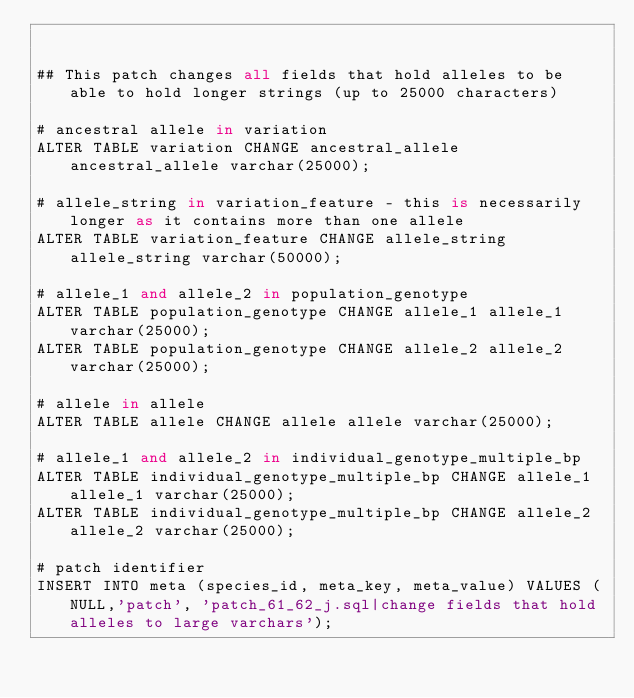<code> <loc_0><loc_0><loc_500><loc_500><_SQL_>

## This patch changes all fields that hold alleles to be able to hold longer strings (up to 25000 characters)

# ancestral allele in variation
ALTER TABLE variation CHANGE ancestral_allele ancestral_allele varchar(25000);

# allele_string in variation_feature - this is necessarily longer as it contains more than one allele
ALTER TABLE variation_feature CHANGE allele_string allele_string varchar(50000);

# allele_1 and allele_2 in population_genotype
ALTER TABLE population_genotype CHANGE allele_1 allele_1 varchar(25000);
ALTER TABLE population_genotype CHANGE allele_2 allele_2 varchar(25000);

# allele in allele
ALTER TABLE allele CHANGE allele allele varchar(25000);

# allele_1 and allele_2 in individual_genotype_multiple_bp
ALTER TABLE individual_genotype_multiple_bp CHANGE allele_1 allele_1 varchar(25000);
ALTER TABLE individual_genotype_multiple_bp CHANGE allele_2 allele_2 varchar(25000);

# patch identifier
INSERT INTO meta (species_id, meta_key, meta_value) VALUES (NULL,'patch', 'patch_61_62_j.sql|change fields that hold alleles to large varchars');
</code> 